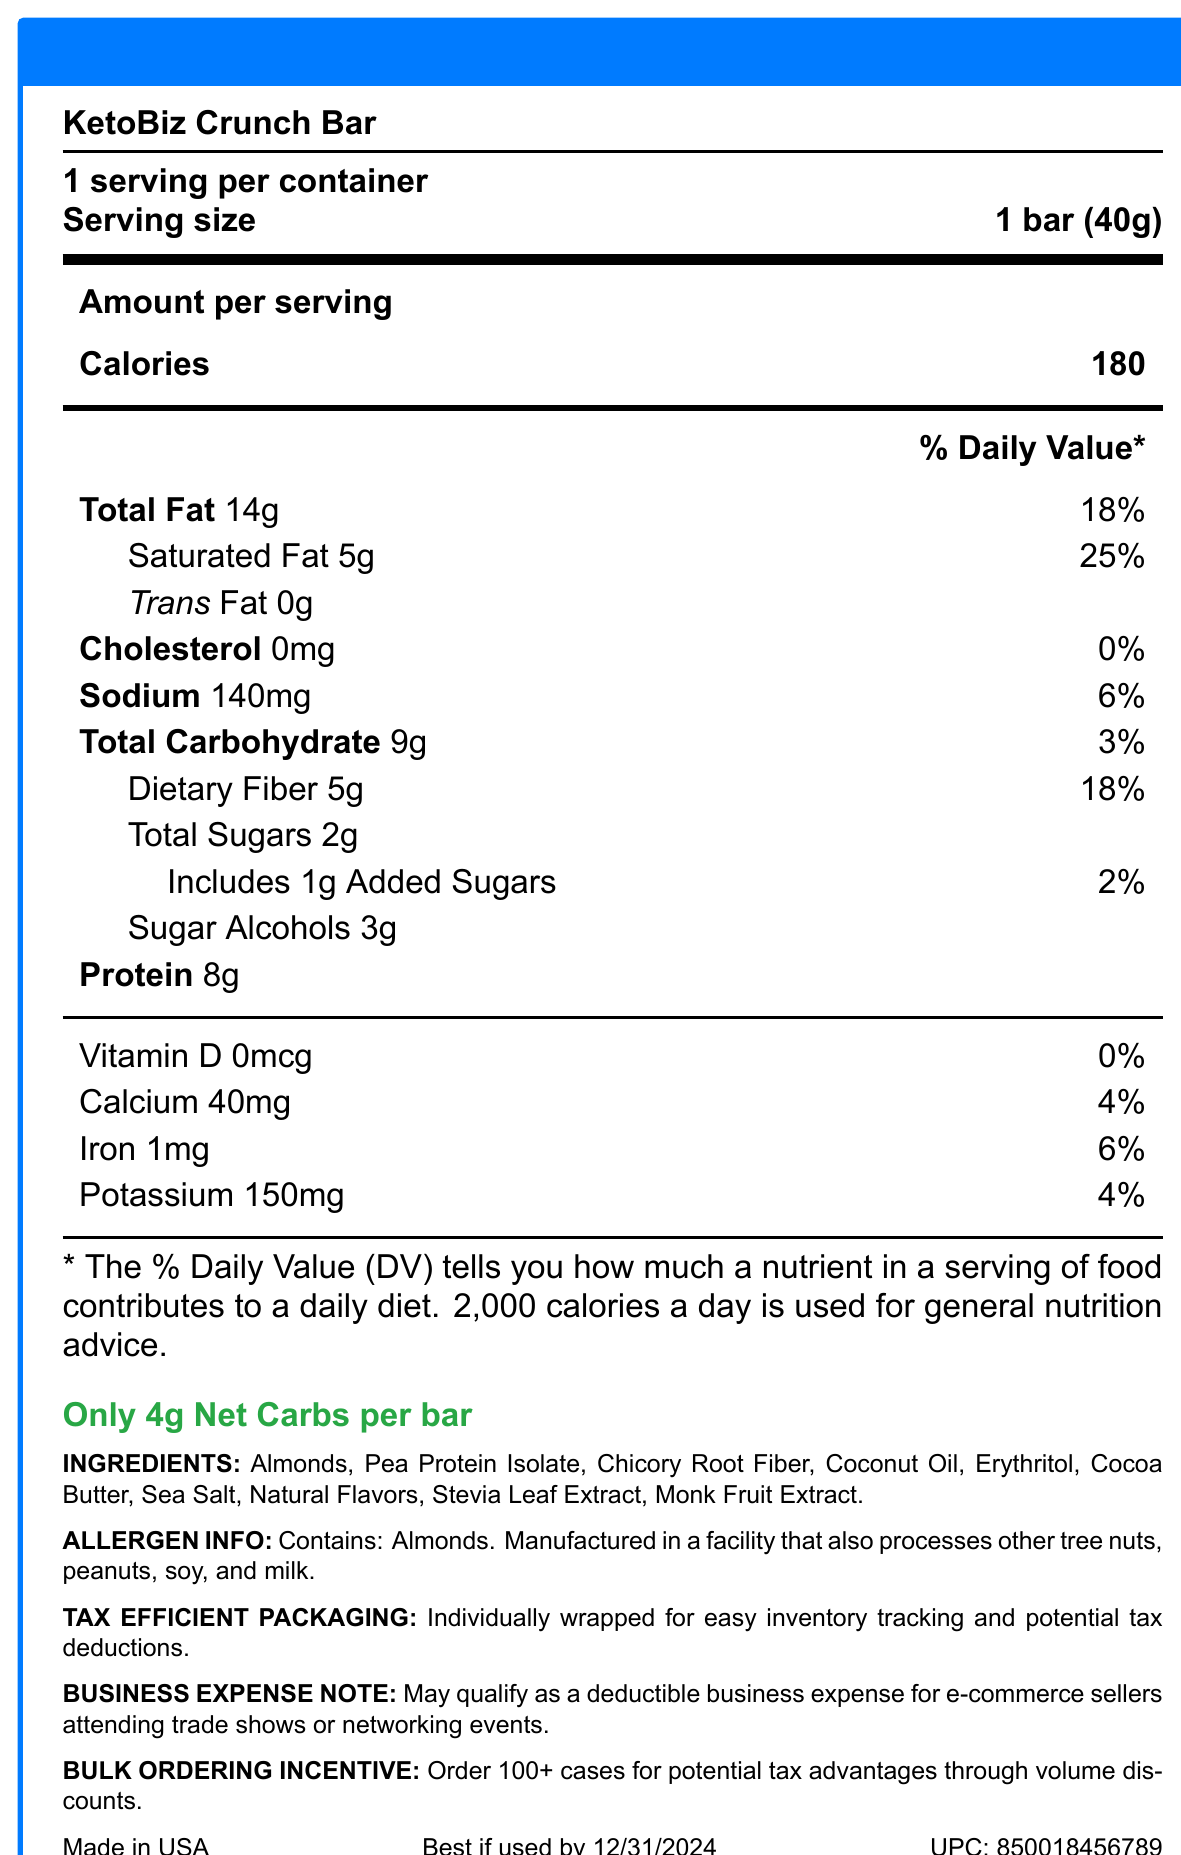what is the name of the product? The product name is clearly stated at the beginning of the document.
Answer: KetoBiz Crunch Bar what is the serving size of the KetoBiz Crunch Bar? The serving size is specified as 1 bar (40g) in the nutrition facts.
Answer: 1 bar (40g) how many calories are in one serving of the KetoBiz Crunch Bar? The document states that each bar contains 180 calories.
Answer: 180 calories what is the total fat content per serving? The total fat content is listed as 14 grams per serving.
Answer: 14g how much dietary fiber does one bar contain? The dietary fiber content per serving is listed as 5 grams.
Answer: 5g if I consume two bars, how much sodium intake would that be? One bar contains 140mg of sodium, so two bars would contain 140mg × 2 = 280mg of sodium.
Answer: 280mg which ingredient is listed first in the ingredients list? Almonds are the first listed ingredient in the ingredients section.
Answer: Almonds does the product contain any allergens? The document mentions that the product contains almonds and is manufactured in a facility that processes other tree nuts, peanuts, soy, and milk.
Answer: Yes what is the percentage of daily value for saturated fat? A. 10% B. 18% C. 25% D. 6% The daily value percentage for saturated fat is listed as 25%.
Answer: C. 25% how many net carbs are in one bar? A. 4g B. 9g C. 2g D. 14g The document prominently highlights that there are only 4 grams of net carbs per bar.
Answer: A. 4g does the KetoBiz Crunch Bar contain any trans fat? The nutrition facts indicate that the bar contains 0 grams of trans fat.
Answer: No how much potassium is present per serving of the KetoBiz Crunch Bar? The potassium content is listed as 150mg per serving.
Answer: 150mg what is the expiration date of the KetoBiz Crunch Bar? The document states that the bar is best if used by 12/31/2024.
Answer: 12/31/2024 what is the business expense note about the KetoBiz Crunch Bar? The document includes a note that the product may qualify as a deductible business expense for e-commerce sellers attending trade shows or networking events.
Answer: May qualify as a deductible business expense for e-commerce sellers attending trade shows or networking events are there any special incentives for bulk ordering? The document mentions that ordering 100+ cases offers potential tax advantages through volume discounts.
Answer: Yes how many grams of protein are in one serving? The protein content per serving is listed as 8 grams.
Answer: 8g which of the following nutrients does not contribute any percentage to the daily value? A. Cholesterol B. Vitamin D C. Trans Fat D. Added Sugars Vitamin D has a 0% daily value contribution as listed in the document.
Answer: B. Vitamin D how many servings are there per container of the KetoBiz Crunch Bar? The document states there are 12 servings per container.
Answer: 12 servings describe the main idea of the document The document gives complete details about the nutritional values, ingredients, allergen content, special keto claims, shelf life, and potential business-related advantages of the KetoBiz Crunch Bar.
Answer: The document provides detailed nutrition facts and product information about the KetoBiz Crunch Bar, a keto-friendly snack aimed at health-conscious e-commerce sellers. It outlines the nutritional content, ingredients, allergen information, tax-deductible benefits, and bulk ordering incentives. what are the exact manufacturing conditions of the KetoBiz Crunch Bar facility? The document specifies that the product is manufactured in a facility that processes tree nuts, peanuts, soy, and milk but does not provide exact manufacturing conditions.
Answer: Not enough information 